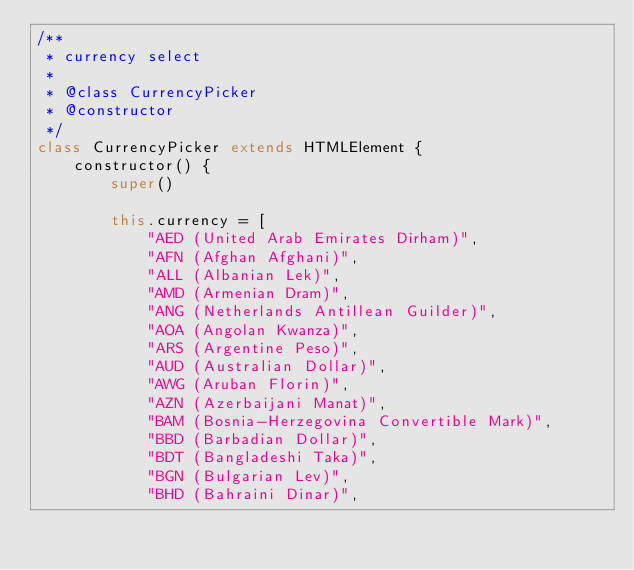Convert code to text. <code><loc_0><loc_0><loc_500><loc_500><_JavaScript_>/**
 * currency select
 * 
 * @class CurrencyPicker
 * @constructor
 */
class CurrencyPicker extends HTMLElement {
    constructor() {
        super()

        this.currency = [
            "AED (United Arab Emirates Dirham)",
            "AFN (Afghan Afghani)",
            "ALL (Albanian Lek)",
            "AMD (Armenian Dram)",
            "ANG (Netherlands Antillean Guilder)",
            "AOA (Angolan Kwanza)",
            "ARS (Argentine Peso)",
            "AUD (Australian Dollar)",
            "AWG (Aruban Florin)",
            "AZN (Azerbaijani Manat)",
            "BAM (Bosnia-Herzegovina Convertible Mark)",
            "BBD (Barbadian Dollar)",
            "BDT (Bangladeshi Taka)",
            "BGN (Bulgarian Lev)",
            "BHD (Bahraini Dinar)",</code> 